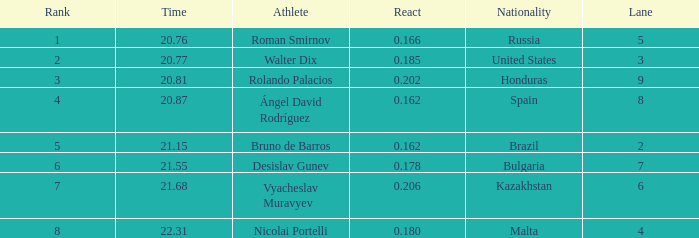What's Bulgaria's lane with a time more than 21.55? None. Write the full table. {'header': ['Rank', 'Time', 'Athlete', 'React', 'Nationality', 'Lane'], 'rows': [['1', '20.76', 'Roman Smirnov', '0.166', 'Russia', '5'], ['2', '20.77', 'Walter Dix', '0.185', 'United States', '3'], ['3', '20.81', 'Rolando Palacios', '0.202', 'Honduras', '9'], ['4', '20.87', 'Ángel David Rodríguez', '0.162', 'Spain', '8'], ['5', '21.15', 'Bruno de Barros', '0.162', 'Brazil', '2'], ['6', '21.55', 'Desislav Gunev', '0.178', 'Bulgaria', '7'], ['7', '21.68', 'Vyacheslav Muravyev', '0.206', 'Kazakhstan', '6'], ['8', '22.31', 'Nicolai Portelli', '0.180', 'Malta', '4']]} 